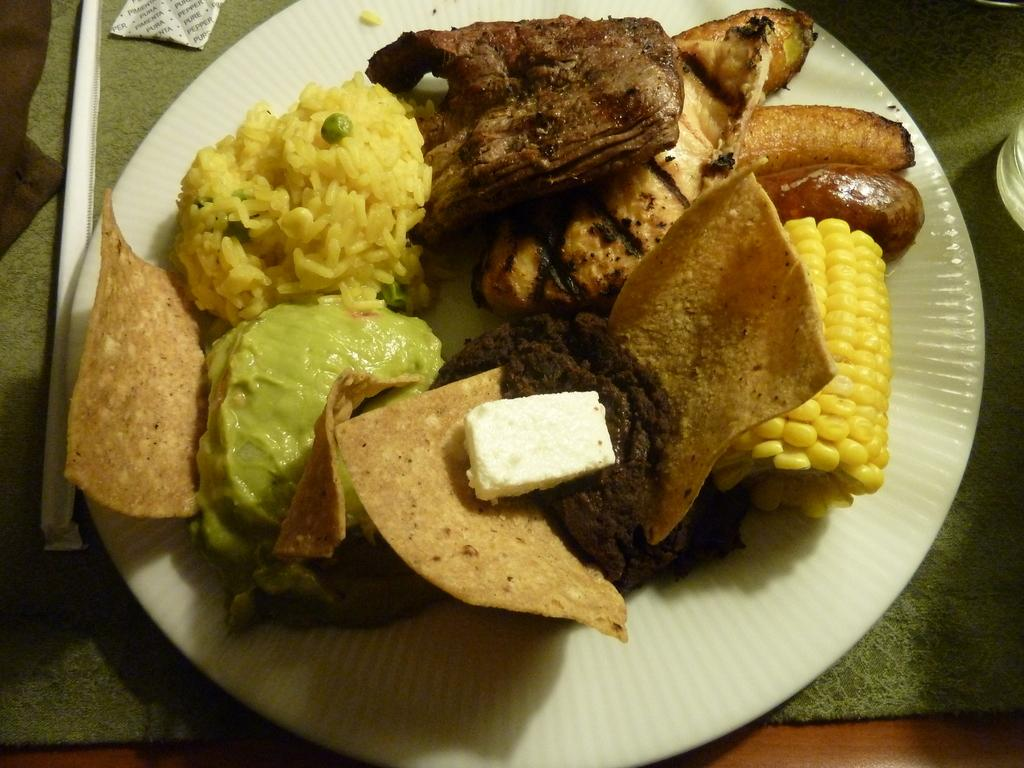What is present in the image related to food? There are food items in the image. How are the food items arranged or contained? The food items are in a plate. Where is the plate with the food items located? The plate is on a platform. Can you tell me how many times the grandmother has visited the pocket in the image? There is no grandmother or pocket present in the image. 